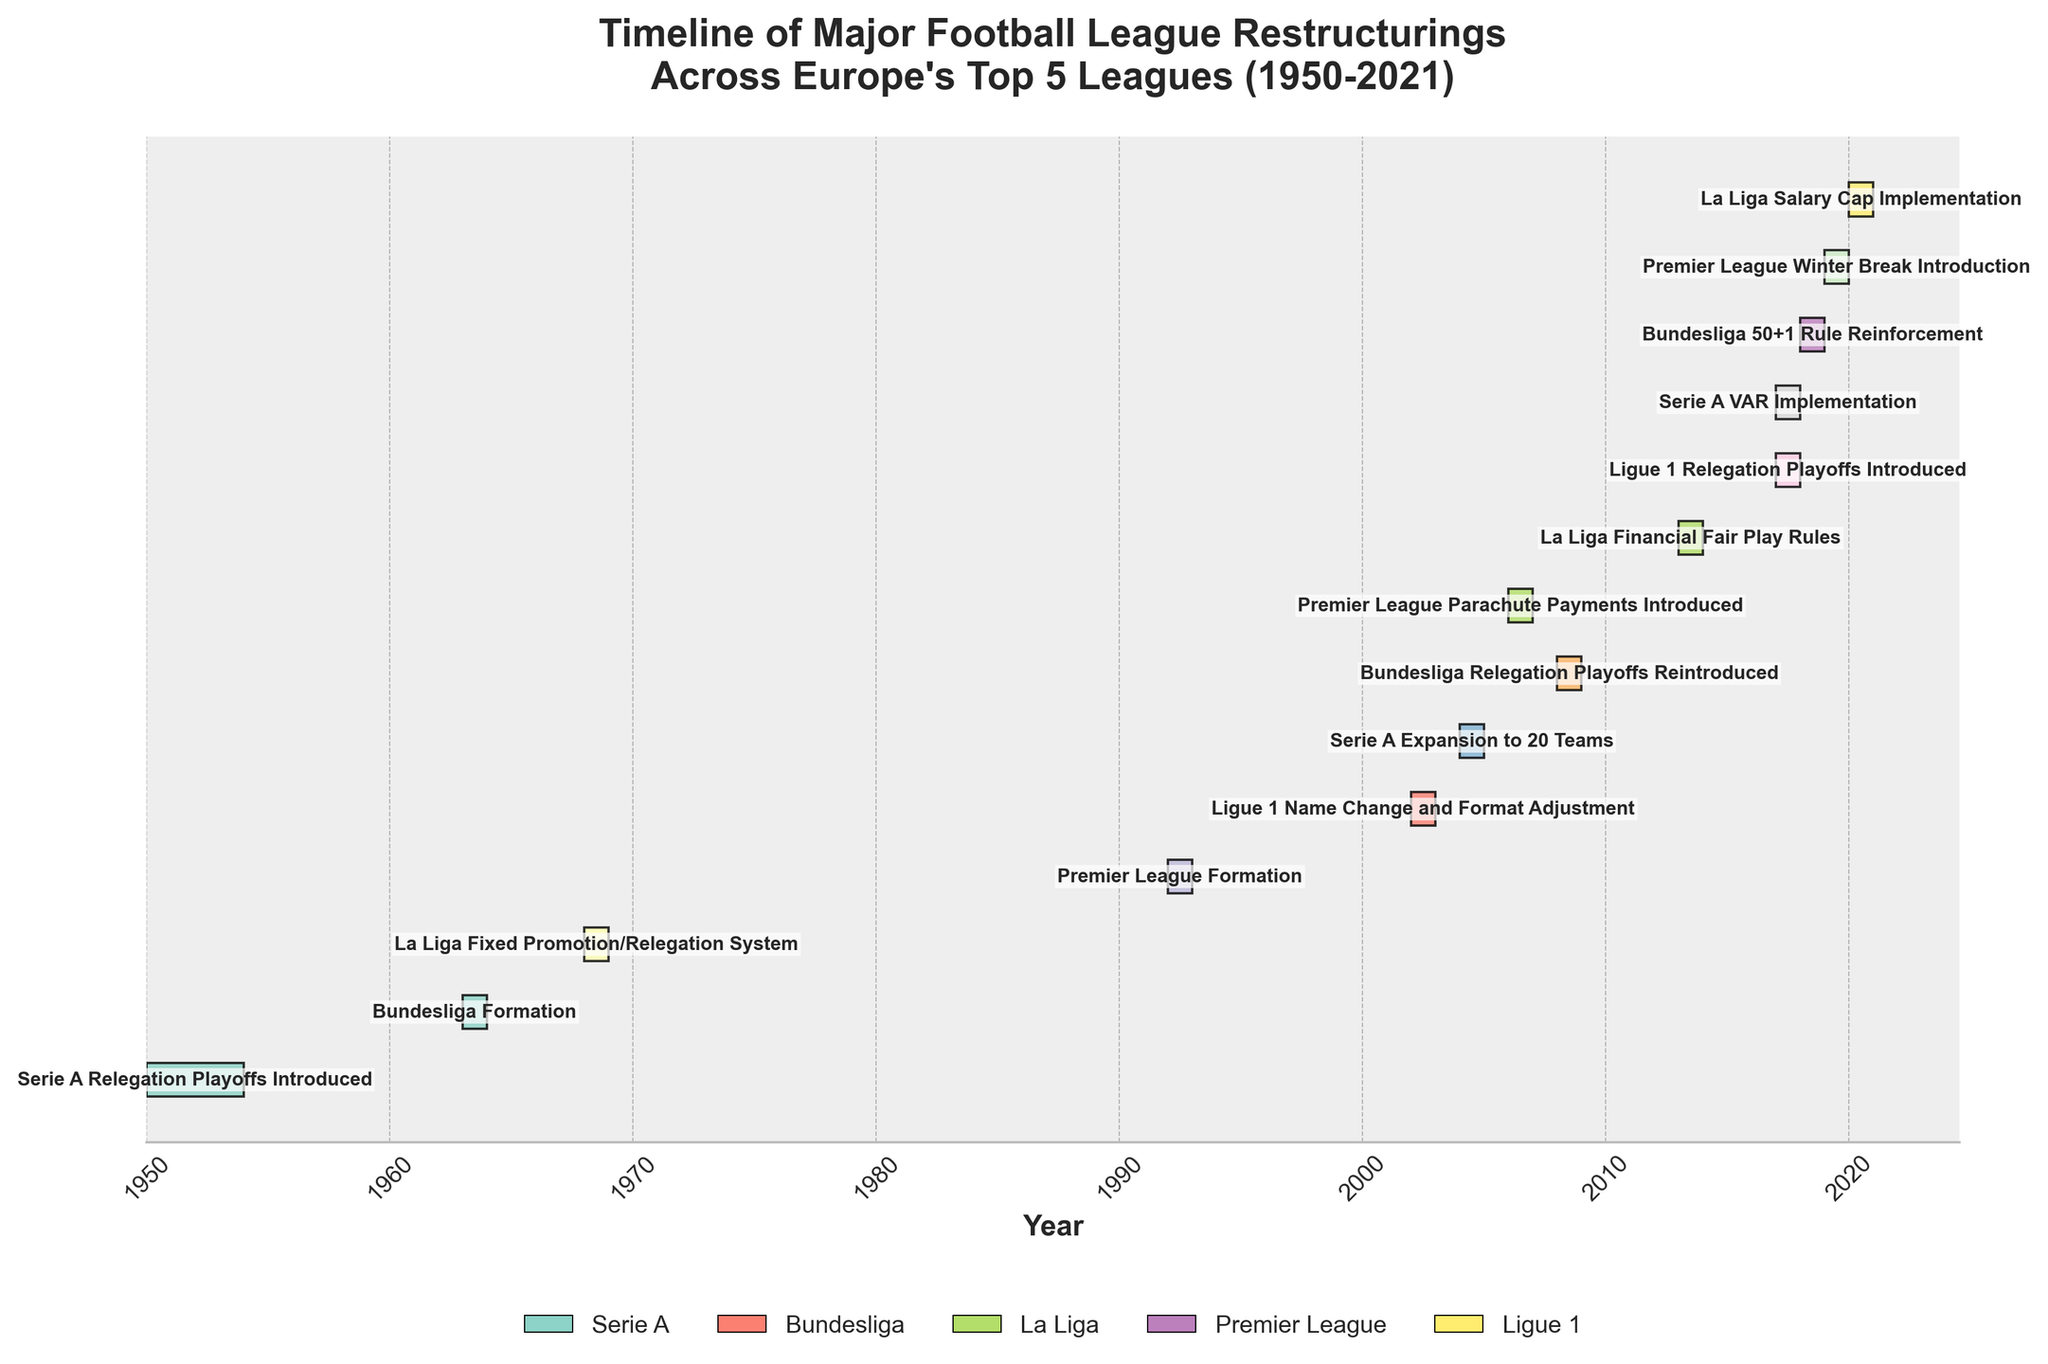what is the title of the plot? The title of the plot is usually located at the top of the figure. In this case, it reads "Timeline of Major Football League Restructurings Across Europe's Top 5 Leagues (1950-2021)."
Answer: Timeline of Major Football League Restructurings Across Europe's Top 5 Leagues (1950-2021) are there any restructuring events in the 1970s? To answer this, you check the timeline on the x-axis marked by years and see if any bars are positioned within the 1970s period.
Answer: No which restructuring event happened first? The figure orders events chronologically from left to right. The first bar from the left marks the earliest event. In this figure, it is "Serie A Relegation Playoffs Introduced."
Answer: Serie A Relegation Playoffs Introduced how many events are related to the Premier League? Identify the bars corresponding to the Premier League by their specific labels. There are three events: "Premier League Formation," "Premier League Parachute Payments Introduced," and "Premier League Winter Break Introduction."
Answer: 3 what event took place between 1963 and 1964? Look for the bar placed within the timeframe of 1963 and 1964. This bar represents the "Bundesliga Formation" event.
Answer: Bundesliga Formation which league implemented VAR, and when? Find the bar labeled with "VAR Implementation" and determine the league name and the corresponding timeframe. It is "Serie A" in 2017-2018.
Answer: Serie A, 2017-2018 how much time passed between the Serie A expansion to 20 teams and the Bundesliga 50+1 rule reinforcement? Locate the two events and compare their timeframes. "Serie A Expansion to 20 Teams" occurred 2004-2005 and "Bundesliga 50+1 Rule Reinforcement" occurred 2018-2019. Calculate the difference: 2018 - 2005 = 13 years.
Answer: 13 years what is unique about "Ligue 1 Relegation Playoffs Introduced" compared to other events? Identify distinguishing features. Unlike most events, "Ligue 1 Relegation Playoffs Introduced" aligns with the latest time bracket displayed, occurring in 2017-2018, which is one of the most recent restructuring events.
Answer: Recent restructuring event, 2017-2018 which event happened right after the Premier League Formation, and in what timeframe? The next visible event after the "Premier League Formation" is "Ligue 1 Name Change and Format Adjustment." It took place between 2002 and 2003.
Answer: Ligue 1 Name Change and Format Adjustment, 2002-2003 